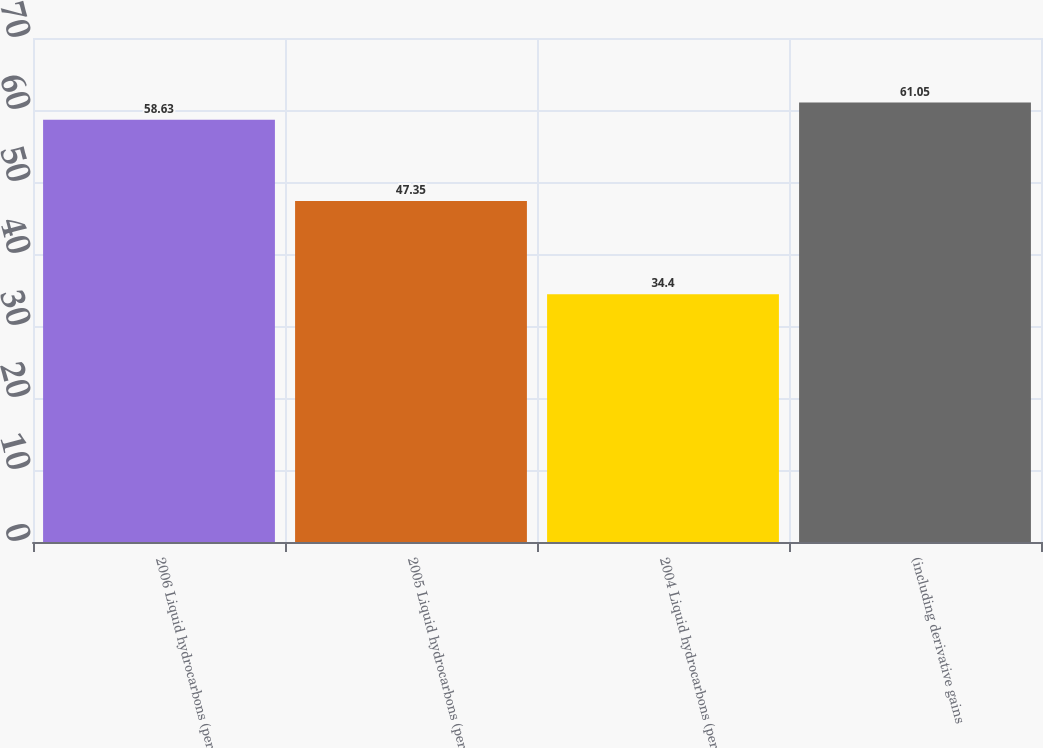Convert chart to OTSL. <chart><loc_0><loc_0><loc_500><loc_500><bar_chart><fcel>2006 Liquid hydrocarbons (per<fcel>2005 Liquid hydrocarbons (per<fcel>2004 Liquid hydrocarbons (per<fcel>(including derivative gains<nl><fcel>58.63<fcel>47.35<fcel>34.4<fcel>61.05<nl></chart> 